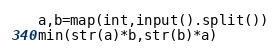Convert code to text. <code><loc_0><loc_0><loc_500><loc_500><_Python_>a,b=map(int,input().split())
min(str(a)*b,str(b)*a)</code> 